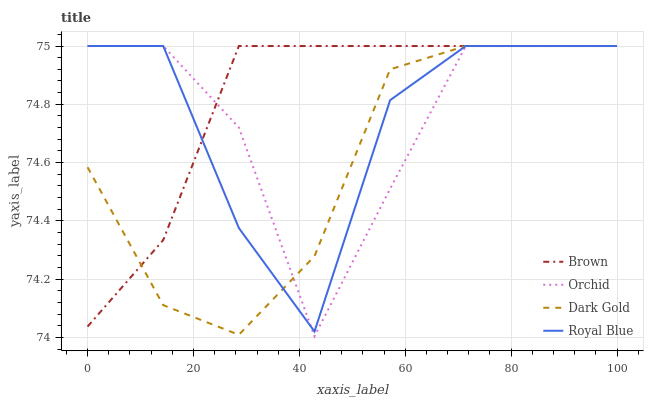Does Dark Gold have the minimum area under the curve?
Answer yes or no. Yes. Does Brown have the maximum area under the curve?
Answer yes or no. Yes. Does Royal Blue have the minimum area under the curve?
Answer yes or no. No. Does Royal Blue have the maximum area under the curve?
Answer yes or no. No. Is Brown the smoothest?
Answer yes or no. Yes. Is Royal Blue the roughest?
Answer yes or no. Yes. Is Dark Gold the smoothest?
Answer yes or no. No. Is Dark Gold the roughest?
Answer yes or no. No. Does Orchid have the lowest value?
Answer yes or no. Yes. Does Dark Gold have the lowest value?
Answer yes or no. No. Does Orchid have the highest value?
Answer yes or no. Yes. Does Royal Blue intersect Dark Gold?
Answer yes or no. Yes. Is Royal Blue less than Dark Gold?
Answer yes or no. No. Is Royal Blue greater than Dark Gold?
Answer yes or no. No. 